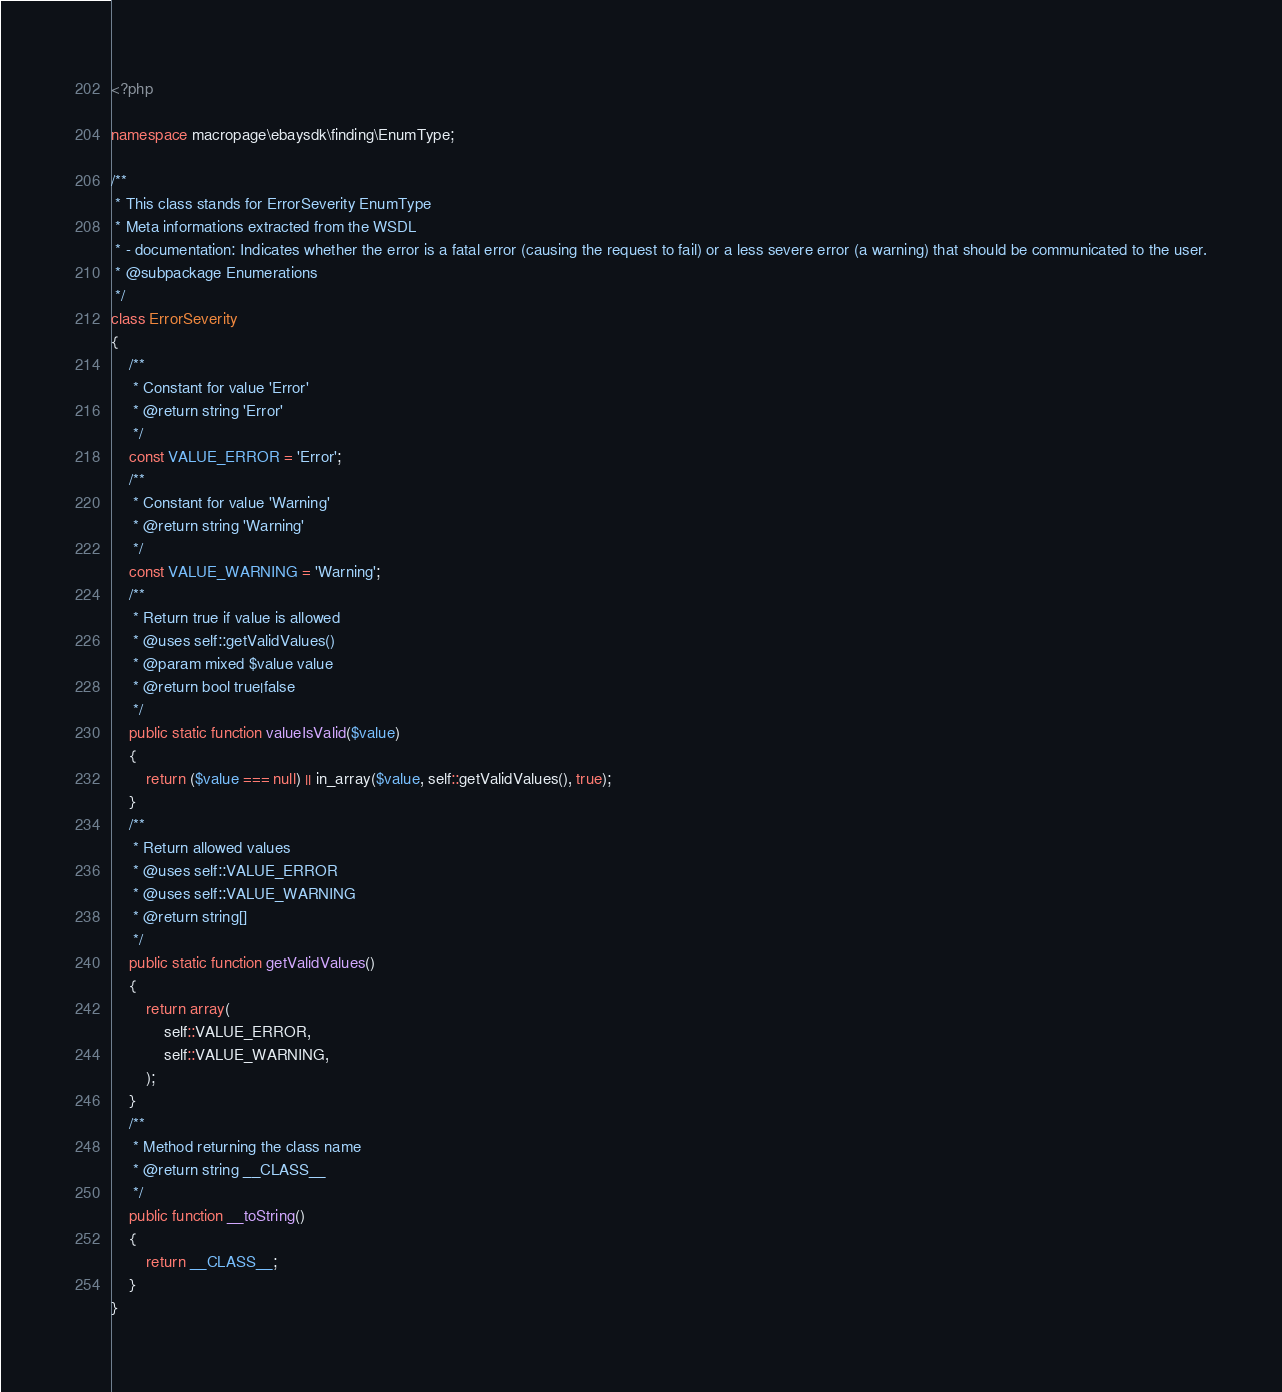Convert code to text. <code><loc_0><loc_0><loc_500><loc_500><_PHP_><?php

namespace macropage\ebaysdk\finding\EnumType;

/**
 * This class stands for ErrorSeverity EnumType
 * Meta informations extracted from the WSDL
 * - documentation: Indicates whether the error is a fatal error (causing the request to fail) or a less severe error (a warning) that should be communicated to the user.
 * @subpackage Enumerations
 */
class ErrorSeverity
{
    /**
     * Constant for value 'Error'
     * @return string 'Error'
     */
    const VALUE_ERROR = 'Error';
    /**
     * Constant for value 'Warning'
     * @return string 'Warning'
     */
    const VALUE_WARNING = 'Warning';
    /**
     * Return true if value is allowed
     * @uses self::getValidValues()
     * @param mixed $value value
     * @return bool true|false
     */
    public static function valueIsValid($value)
    {
        return ($value === null) || in_array($value, self::getValidValues(), true);
    }
    /**
     * Return allowed values
     * @uses self::VALUE_ERROR
     * @uses self::VALUE_WARNING
     * @return string[]
     */
    public static function getValidValues()
    {
        return array(
            self::VALUE_ERROR,
            self::VALUE_WARNING,
        );
    }
    /**
     * Method returning the class name
     * @return string __CLASS__
     */
    public function __toString()
    {
        return __CLASS__;
    }
}
</code> 